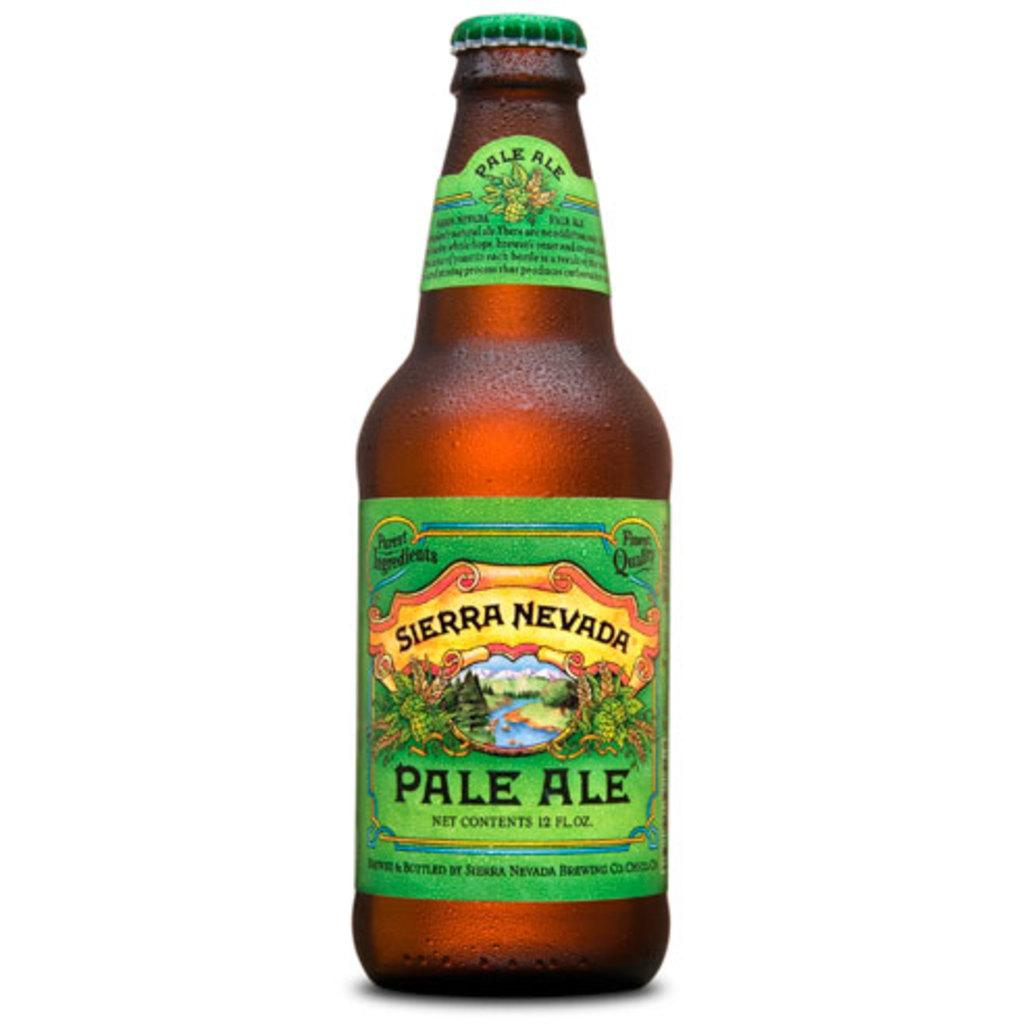<image>
Summarize the visual content of the image. a bottle of Sierra Nevada Pale Ale standing 